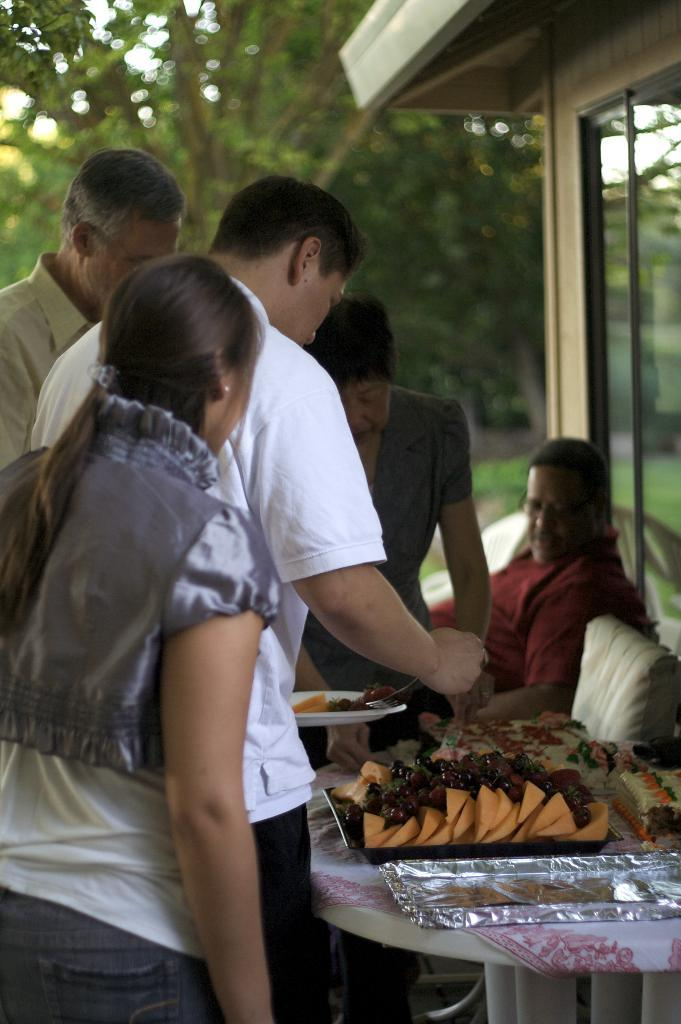Who is present in the image? There are people in the image. What object can be seen in the image that might be used for eating or placing items? There is a table in the image. What type of food is visible in the image? There is a tray of fruits in the image. What is the man in the image doing? A man is serving fruits in the image. What type of cactus is present on the table in the image? There is no cactus present on the table in the image; it is a tray of fruits. How does the man's throat look while serving the fruits in the image? The image does not show the man's throat, so it cannot be determined how it looks while serving the fruits. 